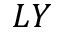Convert formula to latex. <formula><loc_0><loc_0><loc_500><loc_500>L Y</formula> 